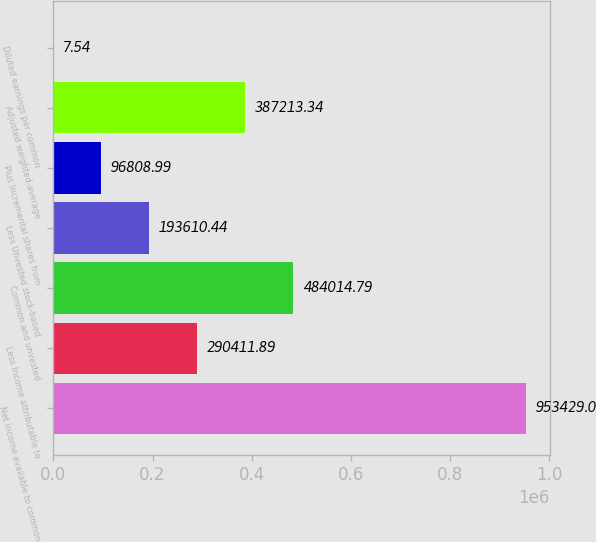Convert chart. <chart><loc_0><loc_0><loc_500><loc_500><bar_chart><fcel>Net income available to common<fcel>Less Income attributable to<fcel>Common and unvested<fcel>Less Unvested stock-based<fcel>Plus Incremental shares from<fcel>Adjusted weighted-average<fcel>Diluted earnings per common<nl><fcel>953429<fcel>290412<fcel>484015<fcel>193610<fcel>96809<fcel>387213<fcel>7.54<nl></chart> 